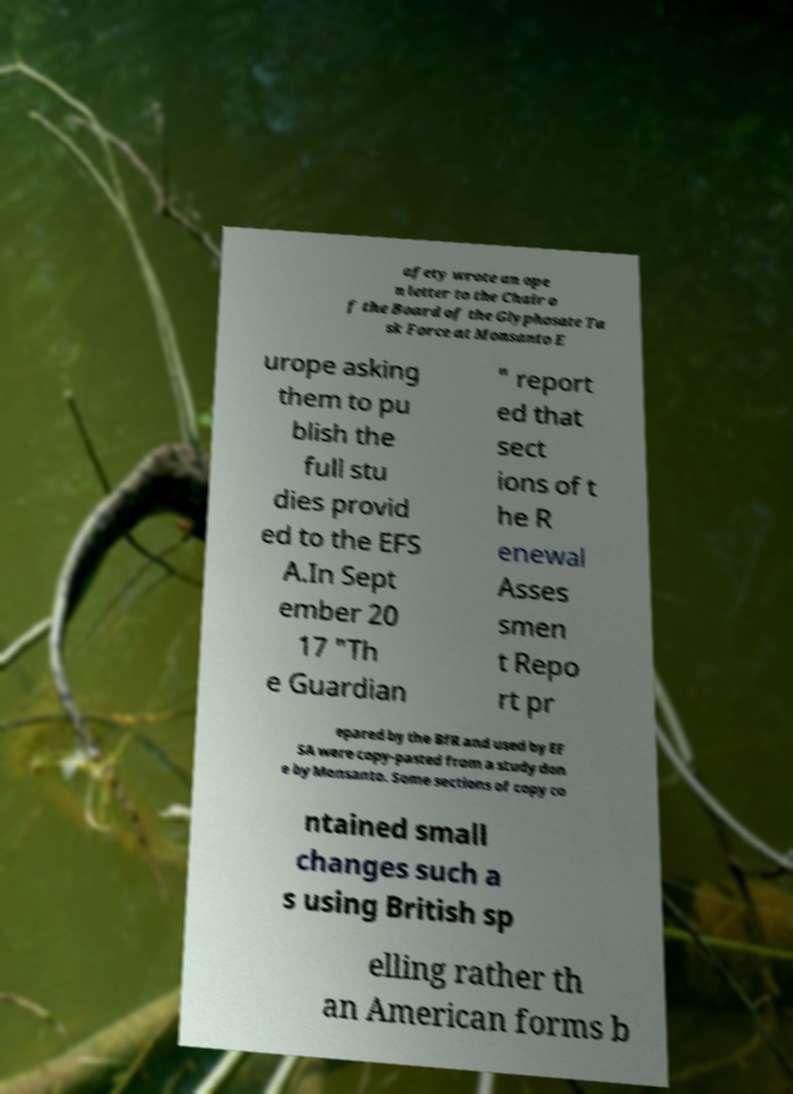Please read and relay the text visible in this image. What does it say? afety wrote an ope n letter to the Chair o f the Board of the Glyphosate Ta sk Force at Monsanto E urope asking them to pu blish the full stu dies provid ed to the EFS A.In Sept ember 20 17 "Th e Guardian " report ed that sect ions of t he R enewal Asses smen t Repo rt pr epared by the BfR and used by EF SA were copy-pasted from a study don e by Monsanto. Some sections of copy co ntained small changes such a s using British sp elling rather th an American forms b 